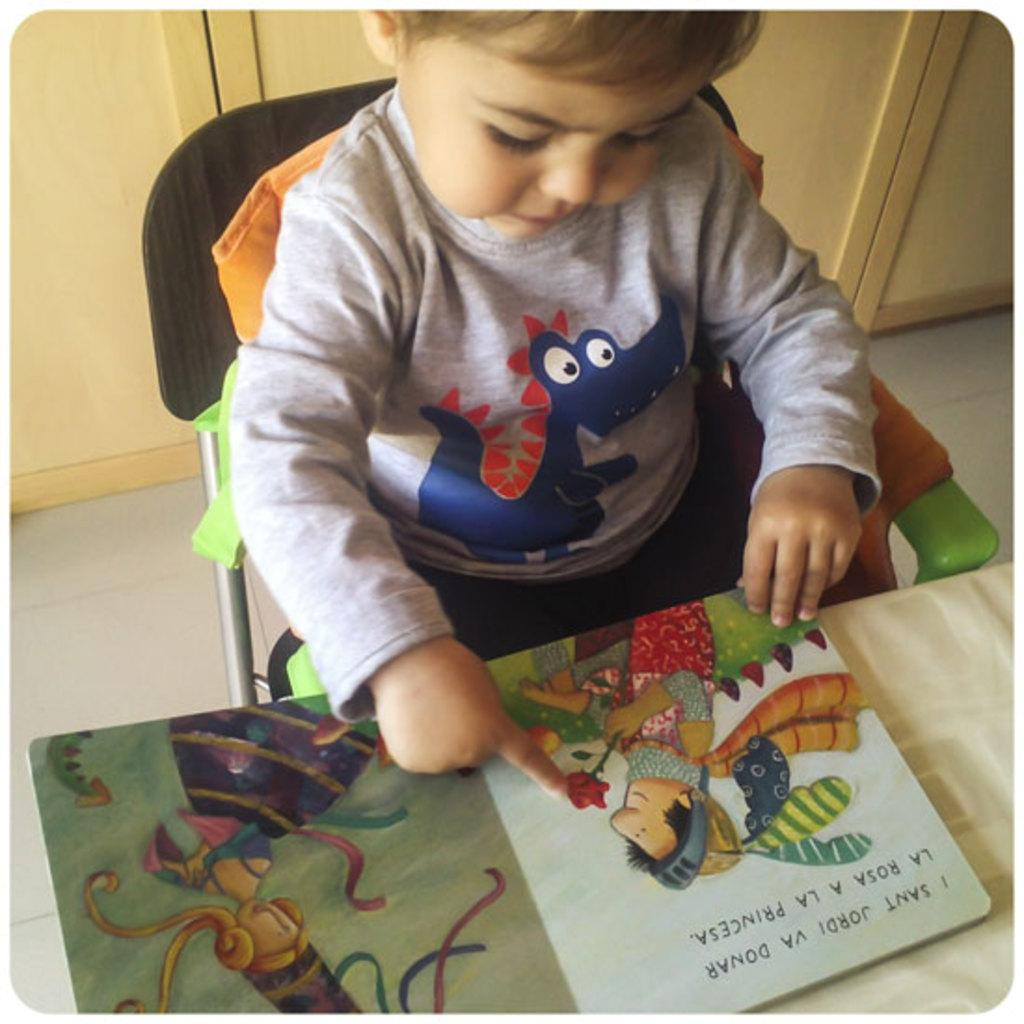What is the main subject of the image? The main subject of the image is a kid. What is the kid doing in the image? The kid is sitting in a chair. What is in front of the kid? There is a book in front of the kid. What can be seen on the book? The book has paintings on it. Where is the book placed? The book is placed on a table. What is visible behind the kid? There are cupboards behind the kid. What type of throat-soothing remedy is visible in the image? There is no throat-soothing remedy present in the image. What brass instrument is the kid playing in the image? There is no brass instrument or any musical instrument visible in the image. 